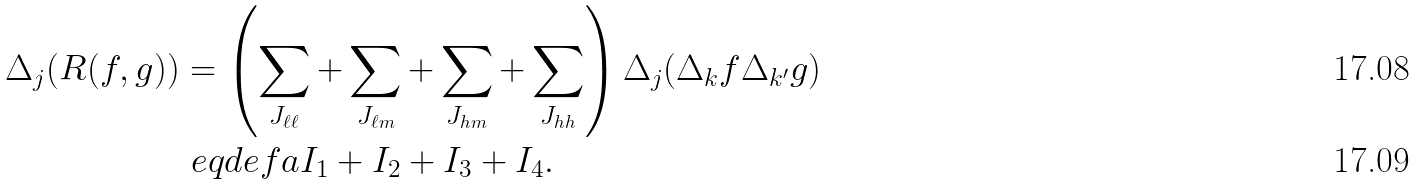Convert formula to latex. <formula><loc_0><loc_0><loc_500><loc_500>\Delta _ { j } ( R ( f , g ) ) & = \left ( \sum _ { J _ { \ell \ell } } + \sum _ { J _ { \ell m } } + \sum _ { J _ { h m } } + \sum _ { J _ { h h } } \right ) \Delta _ { j } ( \Delta _ { k } f { \Delta } _ { k ^ { \prime } } g ) \\ & \ e q d e f a I _ { 1 } + I _ { 2 } + I _ { 3 } + I _ { 4 } .</formula> 